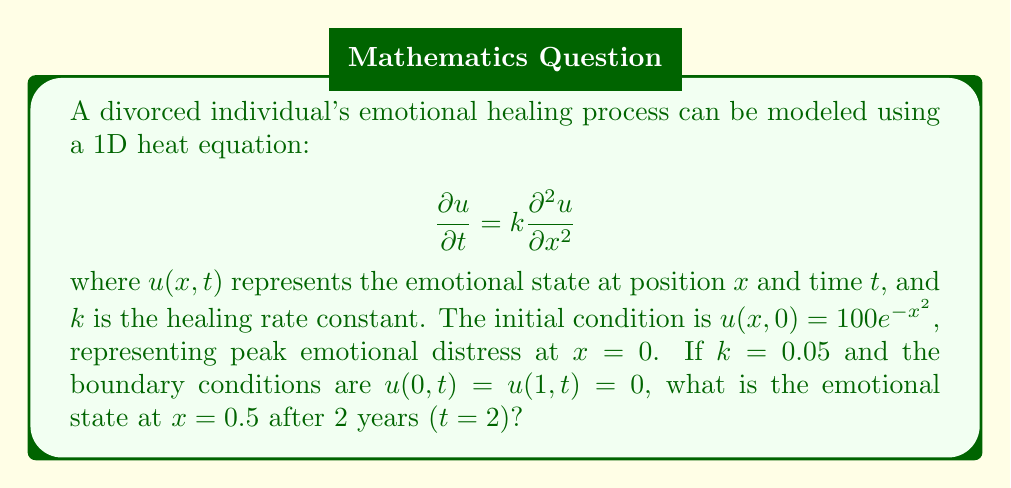Solve this math problem. To solve this heat equation problem, we'll use separation of variables and Fourier series:

1) Assume a solution of the form $u(x,t) = X(x)T(t)$

2) Substituting into the PDE:
   $$X(x)T'(t) = kX''(x)T(t)$$
   $$\frac{T'(t)}{kT(t)} = \frac{X''(x)}{X(x)} = -\lambda^2$$

3) This gives us two ODEs:
   $$T'(t) + k\lambda^2T(t) = 0$$
   $$X''(x) + \lambda^2X(x) = 0$$

4) Given the boundary conditions, we get:
   $$X(x) = \sin(n\pi x), \lambda_n = n\pi, n = 1,2,3,...$$

5) The general solution is:
   $$u(x,t) = \sum_{n=1}^{\infty} b_n \sin(n\pi x)e^{-kn^2\pi^2t}$$

6) To find $b_n$, we use the initial condition:
   $$100e^{-x^2} = \sum_{n=1}^{\infty} b_n \sin(n\pi x)$$

7) Multiply both sides by $\sin(m\pi x)$ and integrate from 0 to 1:
   $$b_n = 200\int_0^1 e^{-x^2}\sin(n\pi x)dx$$

8) This integral doesn't have a closed form, so we'll approximate the first few terms:
   $b_1 \approx 78.5, b_2 \approx 0, b_3 \approx -20.7, b_4 \approx 0, b_5 \approx 2.7$

9) Using these values in our solution for $x=0.5, t=2$:
   $$u(0.5,2) \approx 78.5\sin(0.5\pi)e^{-0.05\pi^2\cdot2} - 20.7\sin(1.5\pi)e^{-0.05(3\pi)^2\cdot2} + 2.7\sin(2.5\pi)e^{-0.05(5\pi)^2\cdot2}$$

10) Calculating this:
    $$u(0.5,2) \approx 19.6$$
Answer: 19.6 